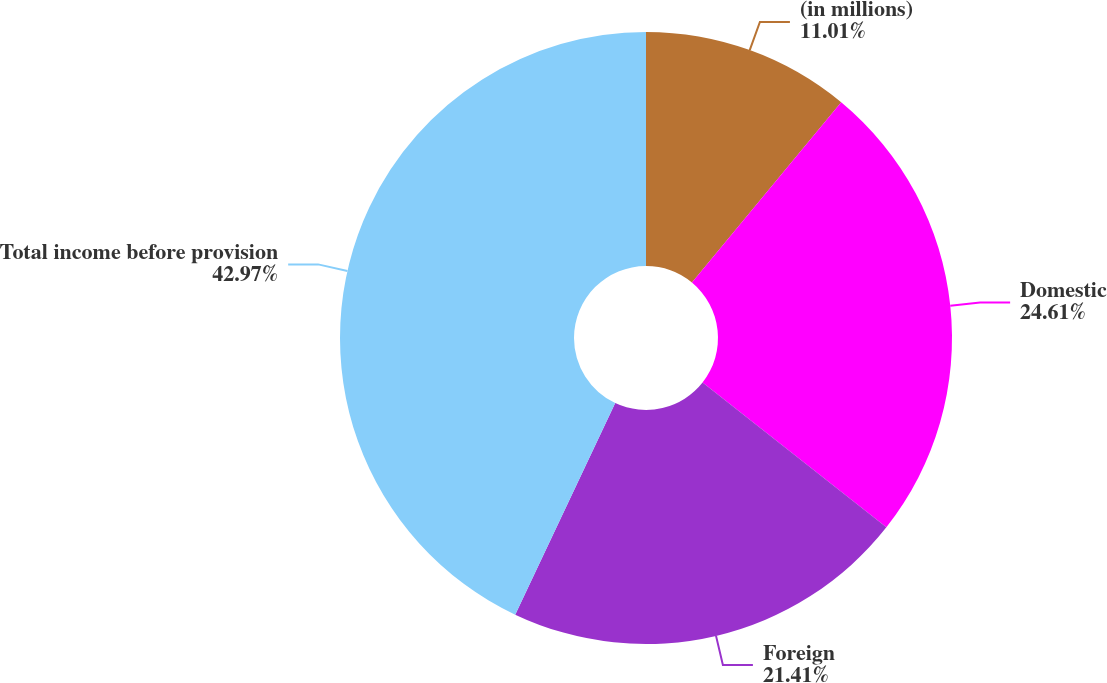Convert chart. <chart><loc_0><loc_0><loc_500><loc_500><pie_chart><fcel>(in millions)<fcel>Domestic<fcel>Foreign<fcel>Total income before provision<nl><fcel>11.01%<fcel>24.61%<fcel>21.41%<fcel>42.97%<nl></chart> 